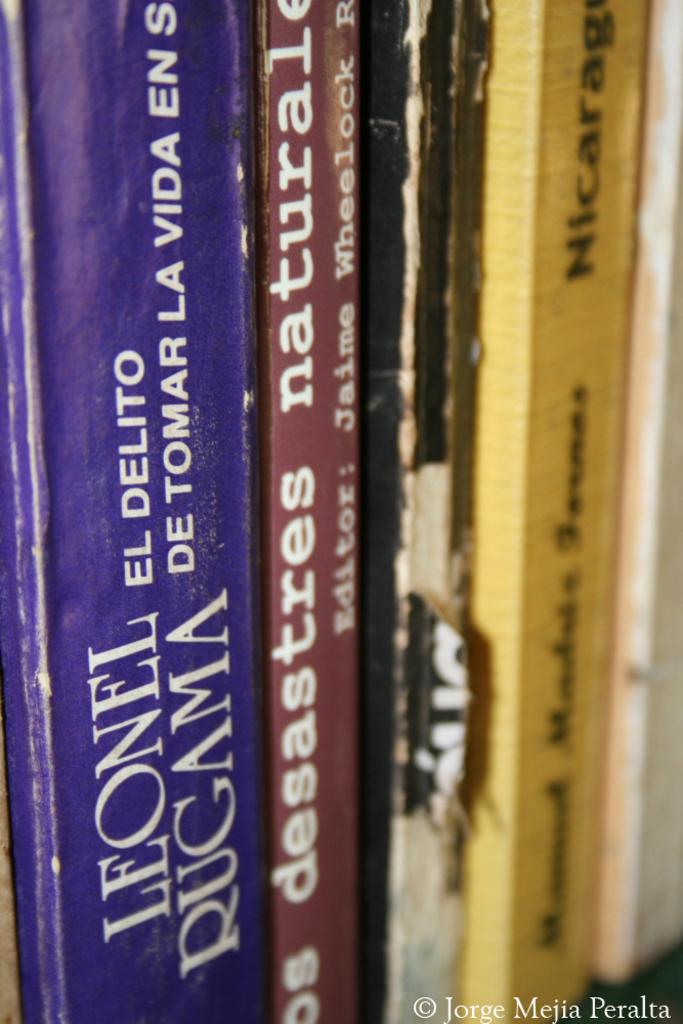What book this leonel rugma write?
Give a very brief answer. El delito de tomar la vida en s. 